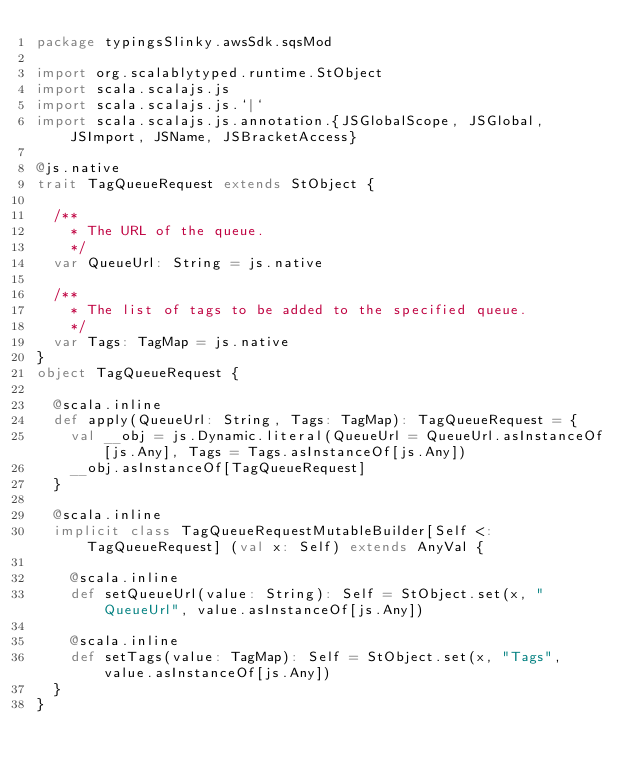<code> <loc_0><loc_0><loc_500><loc_500><_Scala_>package typingsSlinky.awsSdk.sqsMod

import org.scalablytyped.runtime.StObject
import scala.scalajs.js
import scala.scalajs.js.`|`
import scala.scalajs.js.annotation.{JSGlobalScope, JSGlobal, JSImport, JSName, JSBracketAccess}

@js.native
trait TagQueueRequest extends StObject {
  
  /**
    * The URL of the queue.
    */
  var QueueUrl: String = js.native
  
  /**
    * The list of tags to be added to the specified queue.
    */
  var Tags: TagMap = js.native
}
object TagQueueRequest {
  
  @scala.inline
  def apply(QueueUrl: String, Tags: TagMap): TagQueueRequest = {
    val __obj = js.Dynamic.literal(QueueUrl = QueueUrl.asInstanceOf[js.Any], Tags = Tags.asInstanceOf[js.Any])
    __obj.asInstanceOf[TagQueueRequest]
  }
  
  @scala.inline
  implicit class TagQueueRequestMutableBuilder[Self <: TagQueueRequest] (val x: Self) extends AnyVal {
    
    @scala.inline
    def setQueueUrl(value: String): Self = StObject.set(x, "QueueUrl", value.asInstanceOf[js.Any])
    
    @scala.inline
    def setTags(value: TagMap): Self = StObject.set(x, "Tags", value.asInstanceOf[js.Any])
  }
}
</code> 